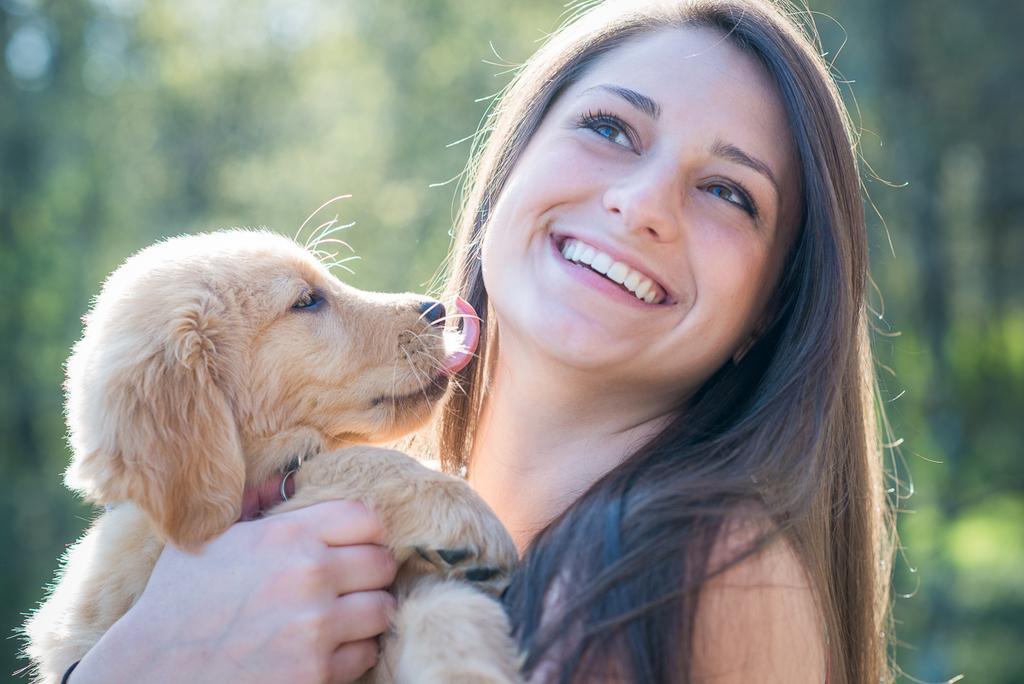How would you summarize this image in a sentence or two? In this image I can see the women standing and smiling. She is holding a puppy in her hand. At the background looks light green in color. 